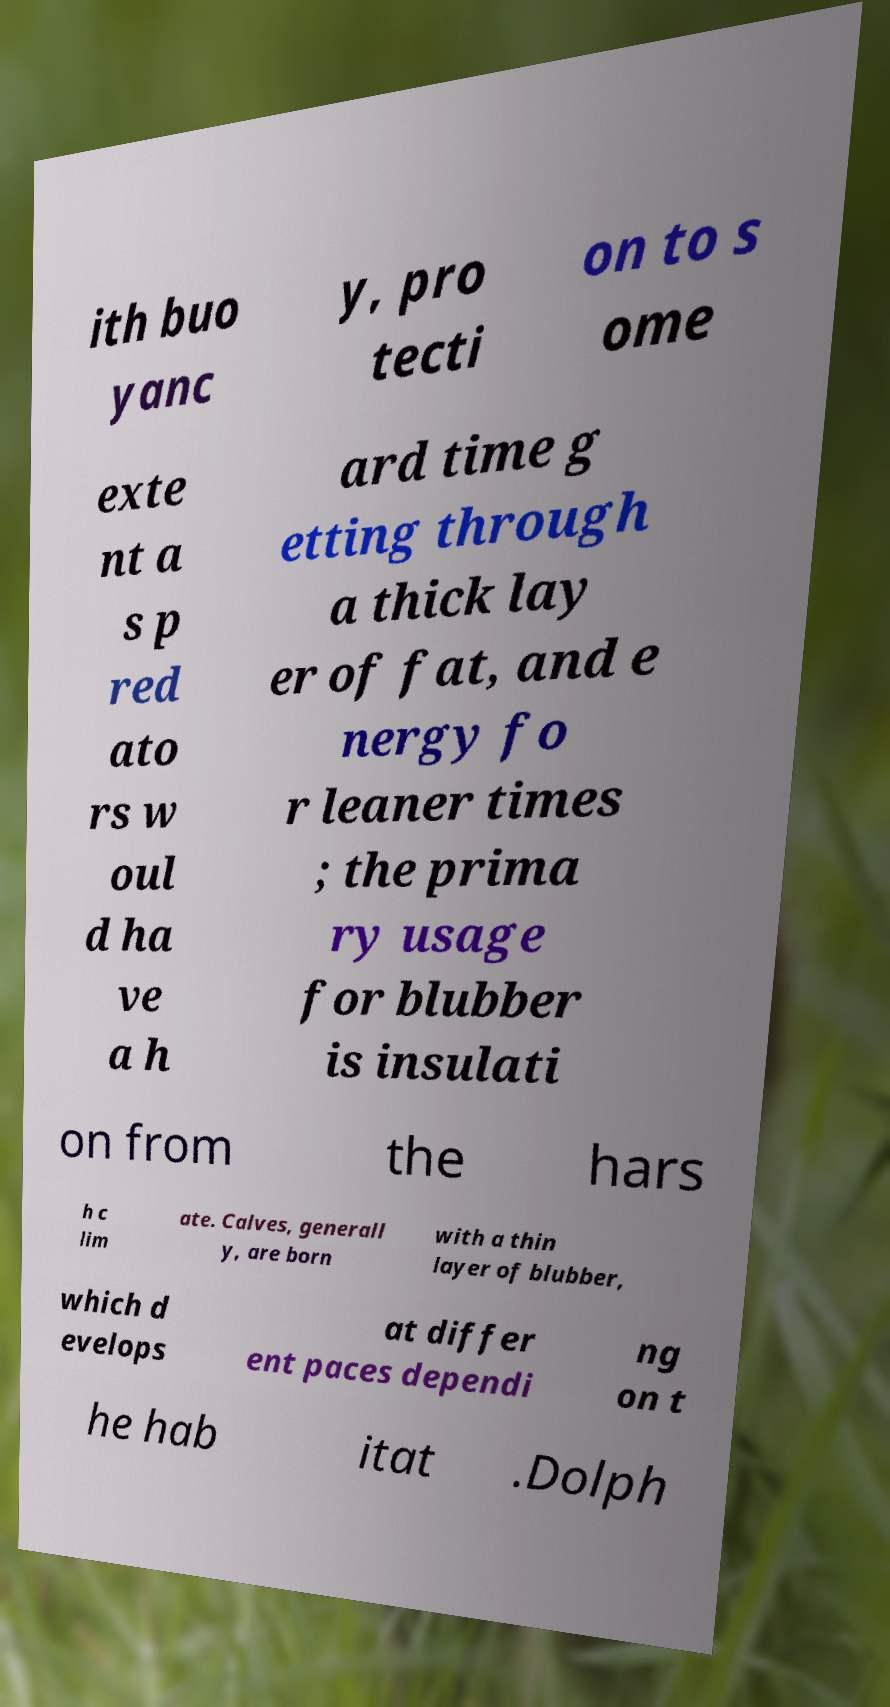For documentation purposes, I need the text within this image transcribed. Could you provide that? ith buo yanc y, pro tecti on to s ome exte nt a s p red ato rs w oul d ha ve a h ard time g etting through a thick lay er of fat, and e nergy fo r leaner times ; the prima ry usage for blubber is insulati on from the hars h c lim ate. Calves, generall y, are born with a thin layer of blubber, which d evelops at differ ent paces dependi ng on t he hab itat .Dolph 